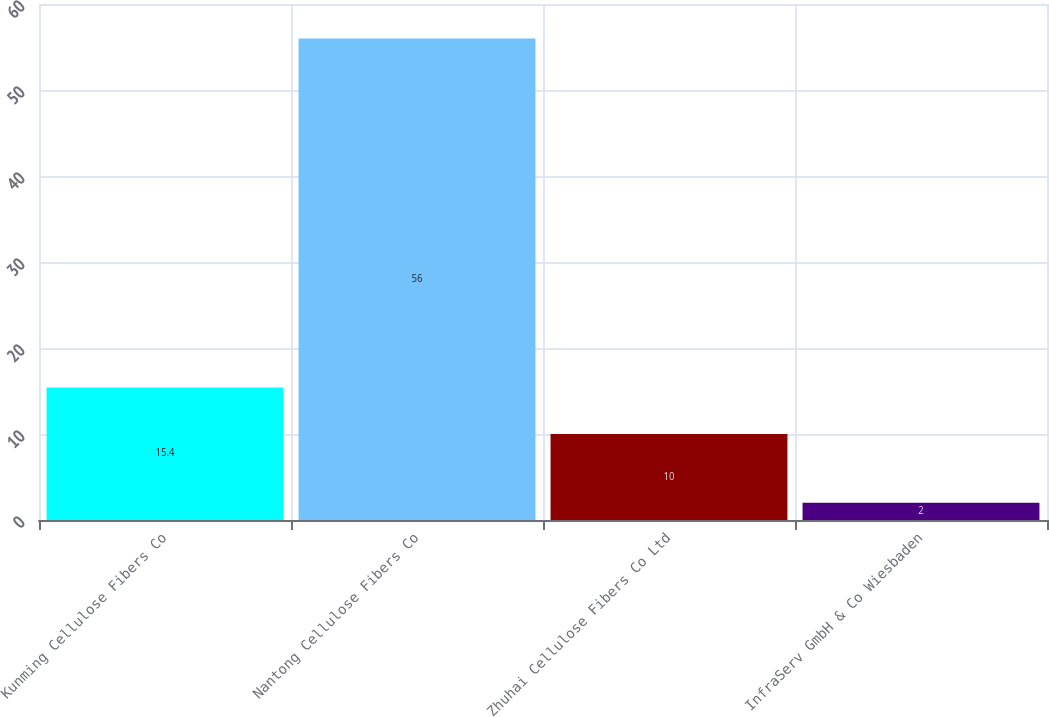<chart> <loc_0><loc_0><loc_500><loc_500><bar_chart><fcel>Kunming Cellulose Fibers Co<fcel>Nantong Cellulose Fibers Co<fcel>Zhuhai Cellulose Fibers Co Ltd<fcel>InfraServ GmbH & Co Wiesbaden<nl><fcel>15.4<fcel>56<fcel>10<fcel>2<nl></chart> 